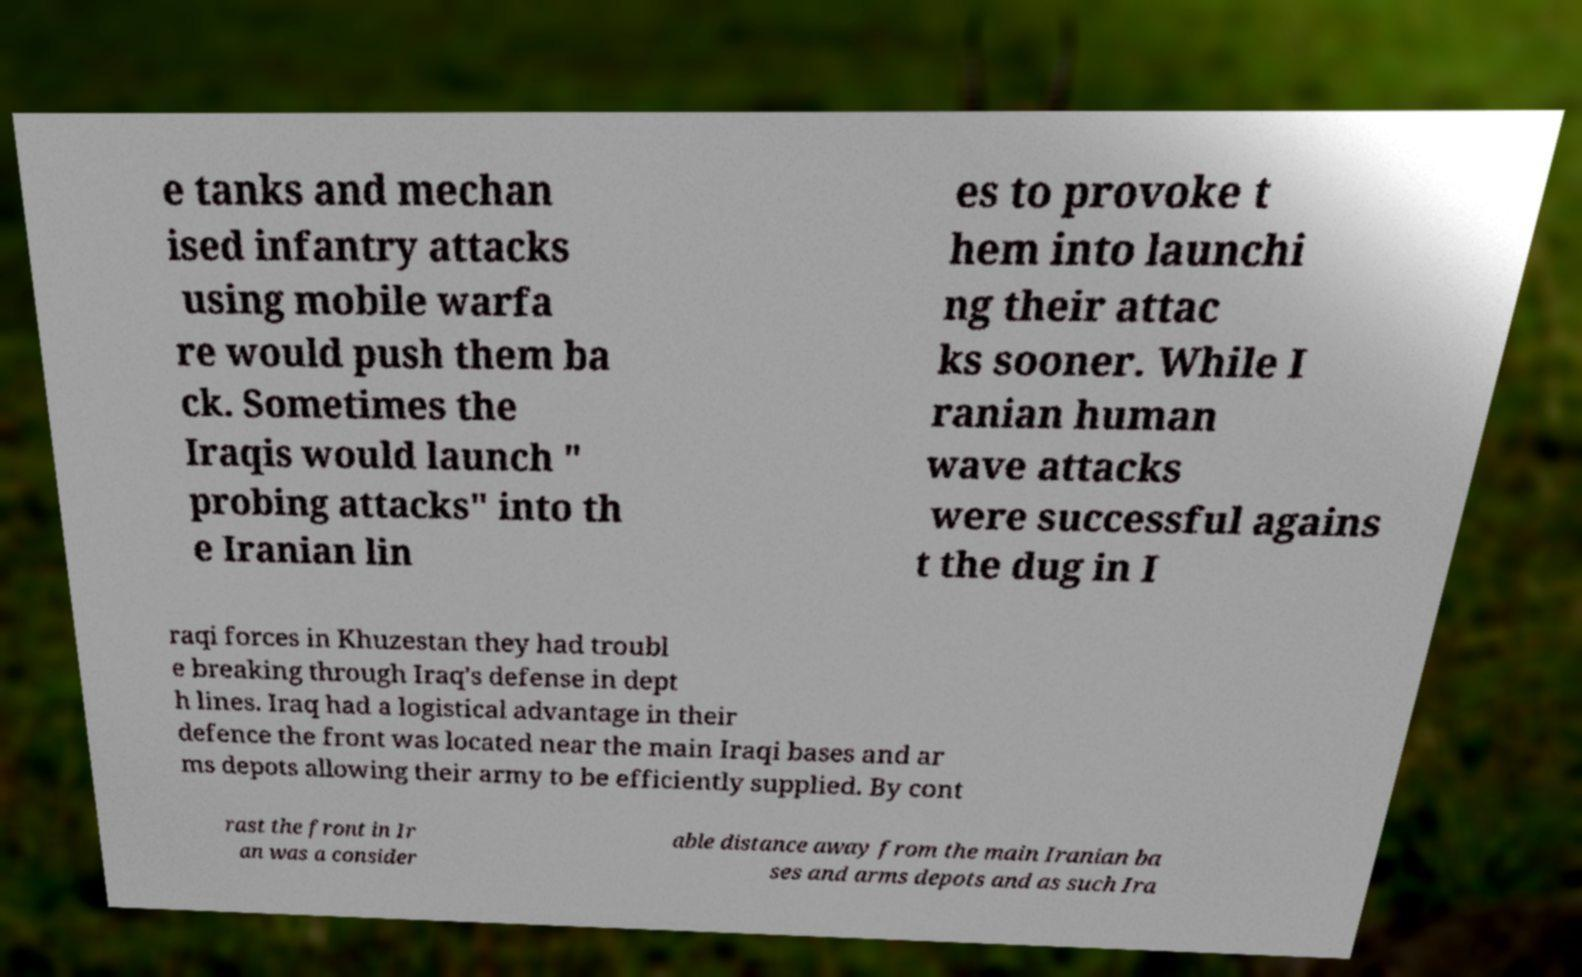Could you assist in decoding the text presented in this image and type it out clearly? e tanks and mechan ised infantry attacks using mobile warfa re would push them ba ck. Sometimes the Iraqis would launch " probing attacks" into th e Iranian lin es to provoke t hem into launchi ng their attac ks sooner. While I ranian human wave attacks were successful agains t the dug in I raqi forces in Khuzestan they had troubl e breaking through Iraq's defense in dept h lines. Iraq had a logistical advantage in their defence the front was located near the main Iraqi bases and ar ms depots allowing their army to be efficiently supplied. By cont rast the front in Ir an was a consider able distance away from the main Iranian ba ses and arms depots and as such Ira 